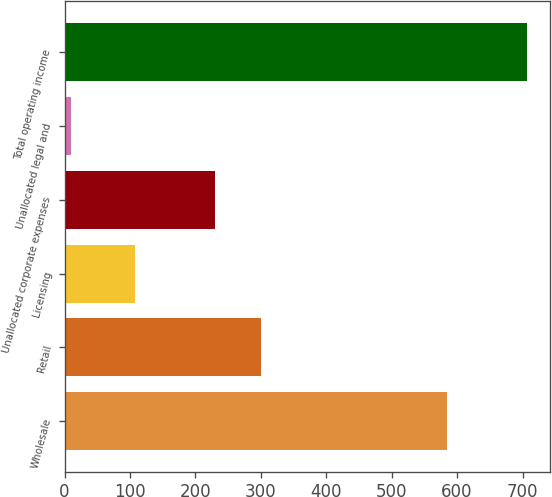Convert chart to OTSL. <chart><loc_0><loc_0><loc_500><loc_500><bar_chart><fcel>Wholesale<fcel>Retail<fcel>Licensing<fcel>Unallocated corporate expenses<fcel>Unallocated legal and<fcel>Total operating income<nl><fcel>585.3<fcel>299.59<fcel>107.4<fcel>229.9<fcel>10<fcel>706.9<nl></chart> 